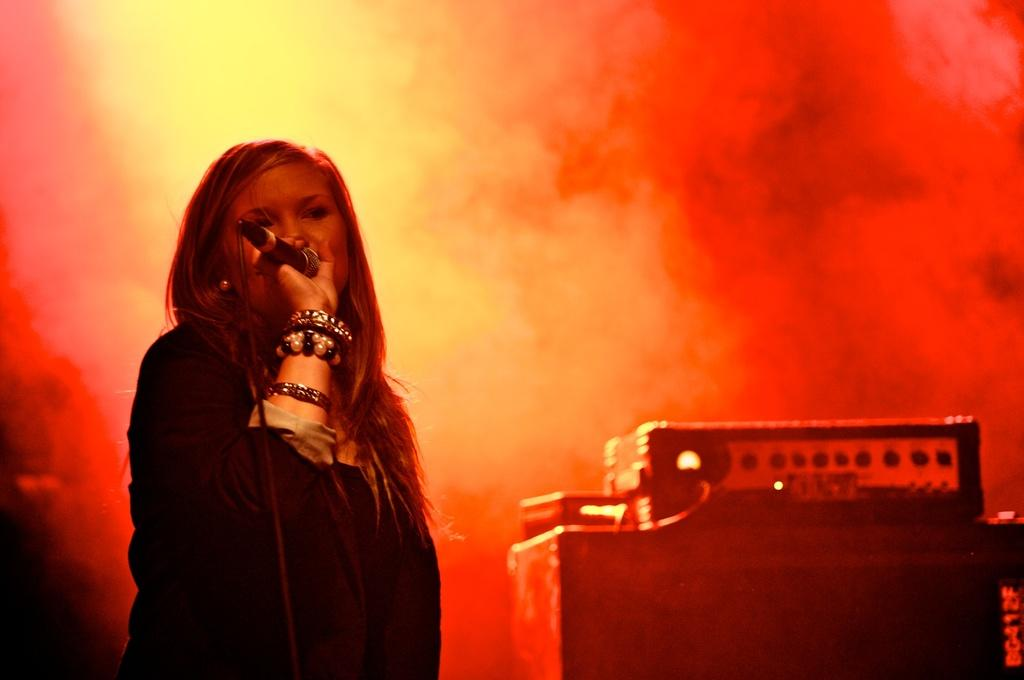Who is the main subject in the image? There is a woman in the image. What is the woman doing in the image? The woman is standing and singing. What object is the woman holding in her hand? The woman is holding a microphone in her hand. What type of twig can be seen in the woman's hair in the image? There is no twig present in the woman's hair in the image. How many frogs are jumping around the woman in the image? There are no frogs present in the image. 